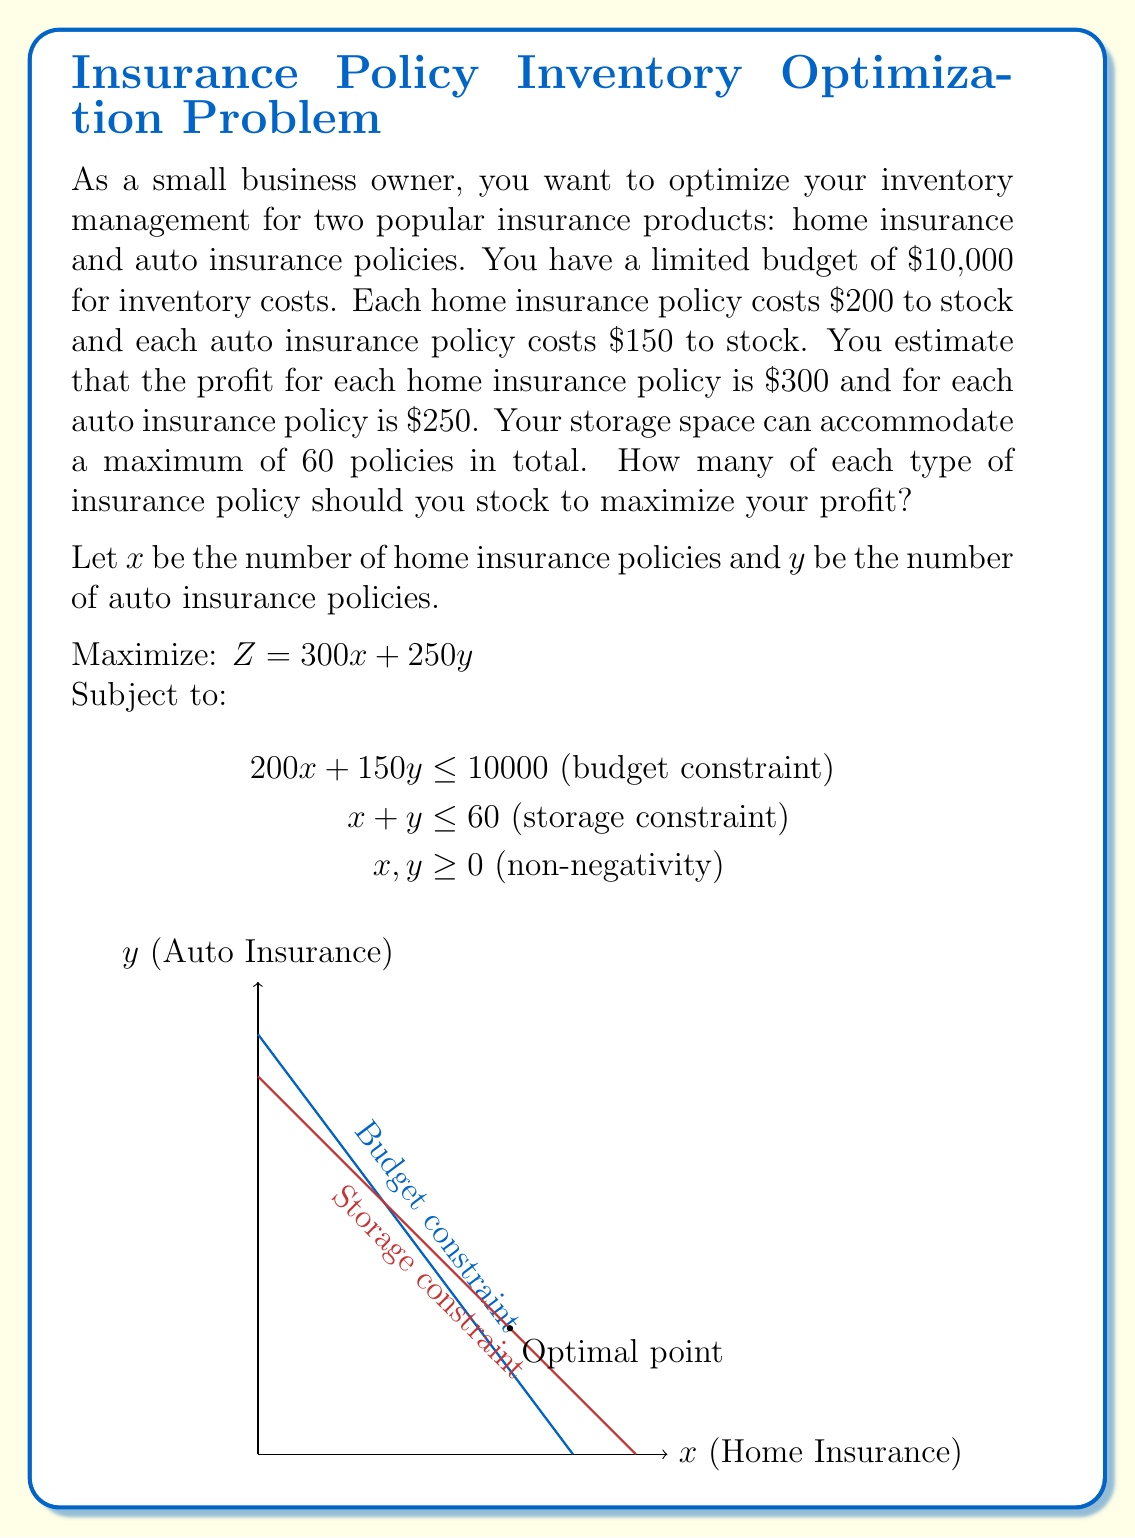Can you solve this math problem? To solve this linear programming problem, we'll use the graphical method:

1) Plot the constraints:
   - Budget: $200x + 150y = 10000$ → $y = 66.67 - 1.33x$
   - Storage: $x + y = 60$

2) Identify the feasible region (the area that satisfies all constraints).

3) Find the corner points of the feasible region:
   A(0, 60), B(0, 66.67), C(50, 0), D(40, 20)

   Point D is found by solving the system of equations:
   $200x + 150y = 10000$
   $x + y = 60$

4) Evaluate the objective function at each corner point:
   A(0, 60):   Z = 300(0) + 250(60) = 15000
   B(0, 66.67): Not feasible (exceeds storage constraint)
   C(50, 0):   Z = 300(50) + 250(0) = 15000
   D(40, 20):  Z = 300(40) + 250(20) = 17000

5) The maximum profit occurs at point D(40, 20).

Therefore, to maximize profit, you should stock 40 home insurance policies and 20 auto insurance policies.
Answer: 40 home insurance policies, 20 auto insurance policies 